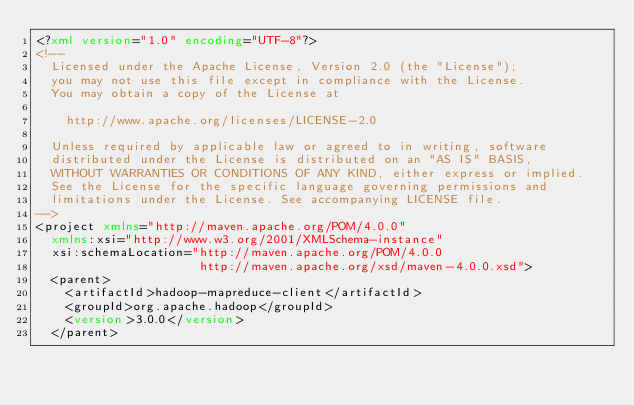<code> <loc_0><loc_0><loc_500><loc_500><_XML_><?xml version="1.0" encoding="UTF-8"?>
<!--
  Licensed under the Apache License, Version 2.0 (the "License");
  you may not use this file except in compliance with the License.
  You may obtain a copy of the License at

    http://www.apache.org/licenses/LICENSE-2.0

  Unless required by applicable law or agreed to in writing, software
  distributed under the License is distributed on an "AS IS" BASIS,
  WITHOUT WARRANTIES OR CONDITIONS OF ANY KIND, either express or implied.
  See the License for the specific language governing permissions and
  limitations under the License. See accompanying LICENSE file.
-->
<project xmlns="http://maven.apache.org/POM/4.0.0"
  xmlns:xsi="http://www.w3.org/2001/XMLSchema-instance"
  xsi:schemaLocation="http://maven.apache.org/POM/4.0.0
                      http://maven.apache.org/xsd/maven-4.0.0.xsd">
  <parent>
    <artifactId>hadoop-mapreduce-client</artifactId>
    <groupId>org.apache.hadoop</groupId>
    <version>3.0.0</version>
  </parent></code> 